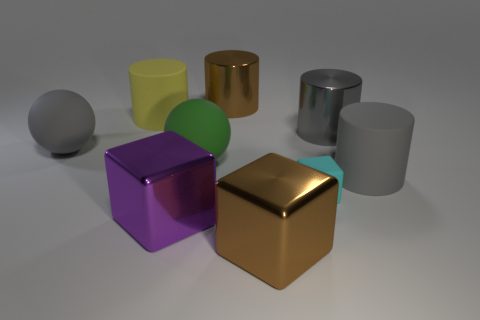Add 1 rubber spheres. How many objects exist? 10 Subtract all spheres. How many objects are left? 7 Subtract all rubber objects. Subtract all large cylinders. How many objects are left? 0 Add 2 big gray matte spheres. How many big gray matte spheres are left? 3 Add 1 matte cubes. How many matte cubes exist? 2 Subtract 0 red cylinders. How many objects are left? 9 